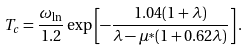Convert formula to latex. <formula><loc_0><loc_0><loc_500><loc_500>T _ { c } = \frac { \omega _ { \ln } } { 1 . 2 } \exp \left [ - \frac { 1 . 0 4 ( 1 + \lambda ) } { \lambda - \mu ^ { * } ( 1 + 0 . 6 2 \lambda ) } \right ] .</formula> 